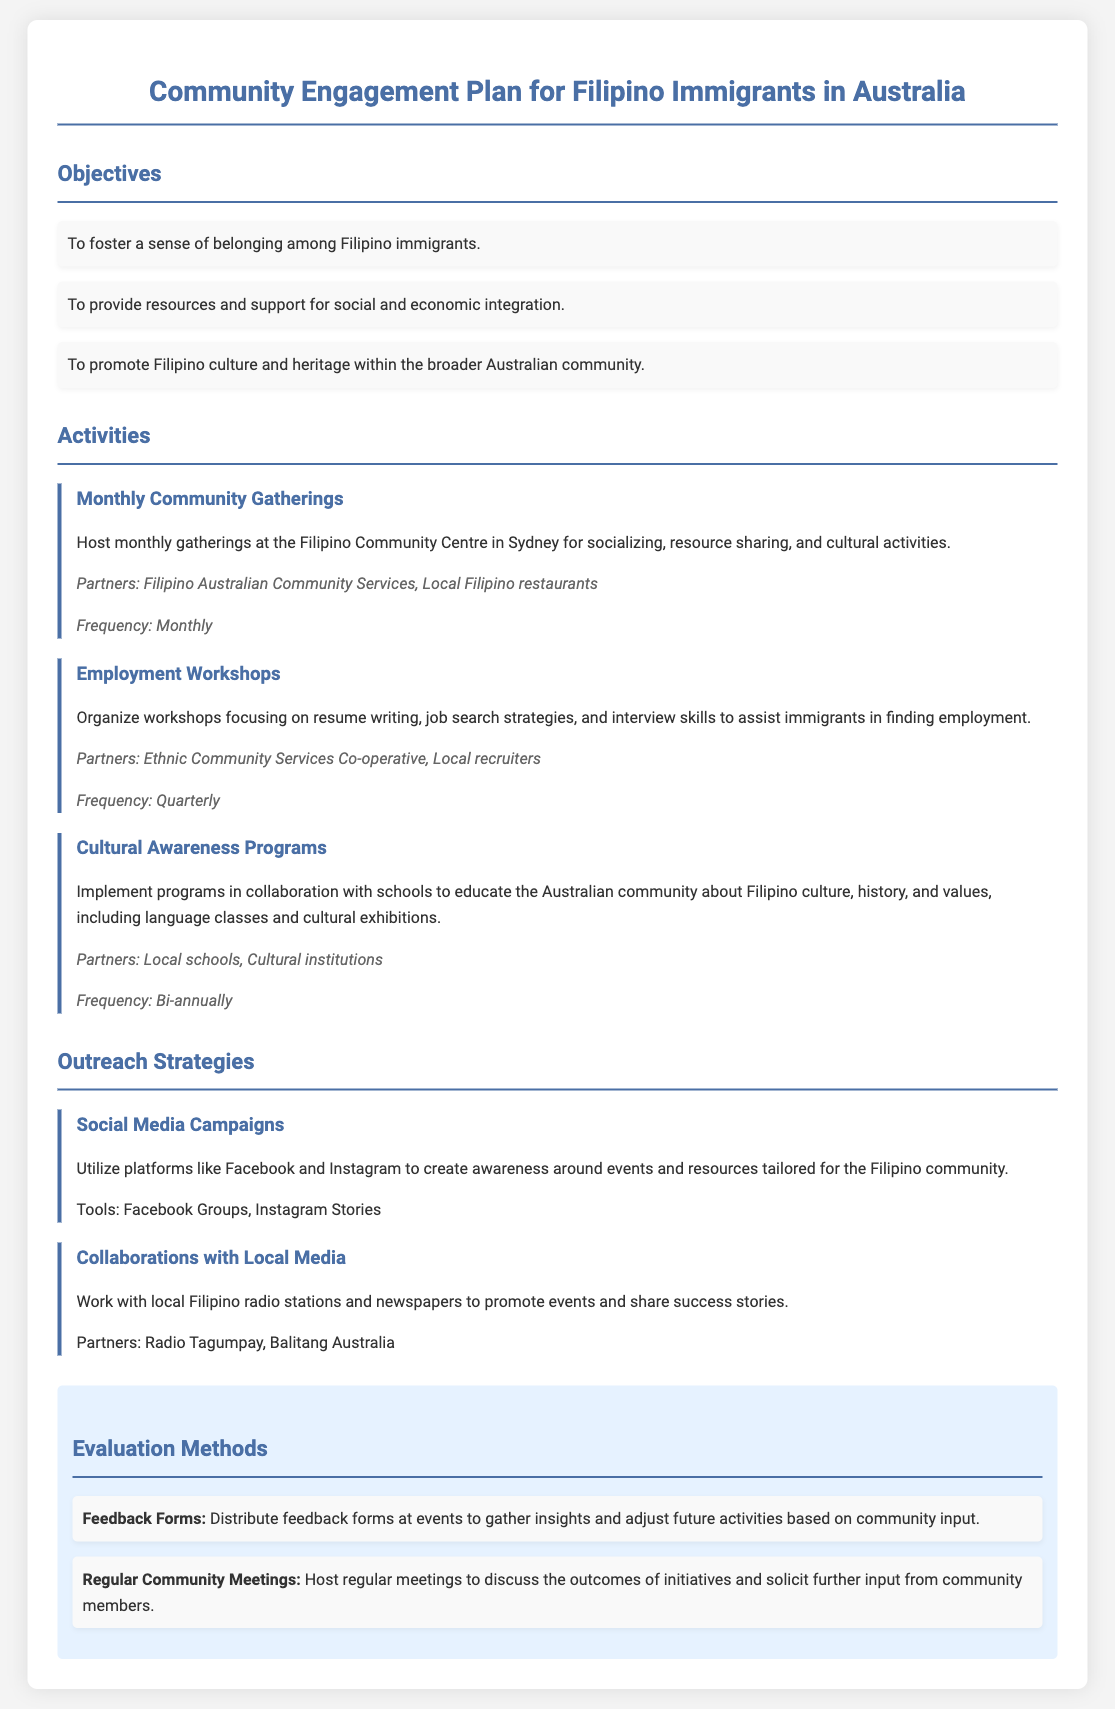What are the objectives of the community engagement plan? The objectives are outlined as fostering belonging, providing resources for integration, and promoting culture.
Answer: To foster a sense of belonging among Filipino immigrants, to provide resources and support for social and economic integration, to promote Filipino culture and heritage within the broader Australian community How often are the monthly community gatherings held? The frequency of the monthly community gatherings indicates how often they occur.
Answer: Monthly What is the title of the first activity listed in the document? The title of the activity gives a clear indication of its purpose and gathering.
Answer: Monthly Community Gatherings Which organization partners with the employment workshops? Identifying partners helps understand collaboration in the activities.
Answer: Ethnic Community Services Co-operative What tool is suggested for creating awareness about Filipino community events? This tool is part of the outreach strategies mentioned in the document.
Answer: Facebook Groups What is the frequency of the cultural awareness programs? This indicates how often cultural programs are implemented, an important part of community engagement.
Answer: Bi-annually What kind of forms are used for evaluation at events? These forms are essential for gathering insights from the community for future improvements.
Answer: Feedback Forms Which local media partners are mentioned for outreach? This information is useful to understand how events are promoted within the community.
Answer: Radio Tagumpay, Balitang Australia 